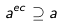<formula> <loc_0><loc_0><loc_500><loc_500>a ^ { e c } \supseteq a</formula> 